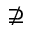<formula> <loc_0><loc_0><loc_500><loc_500>\nsupseteq</formula> 